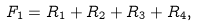Convert formula to latex. <formula><loc_0><loc_0><loc_500><loc_500>F _ { 1 } = R _ { 1 } + R _ { 2 } + R _ { 3 } + R _ { 4 } ,</formula> 